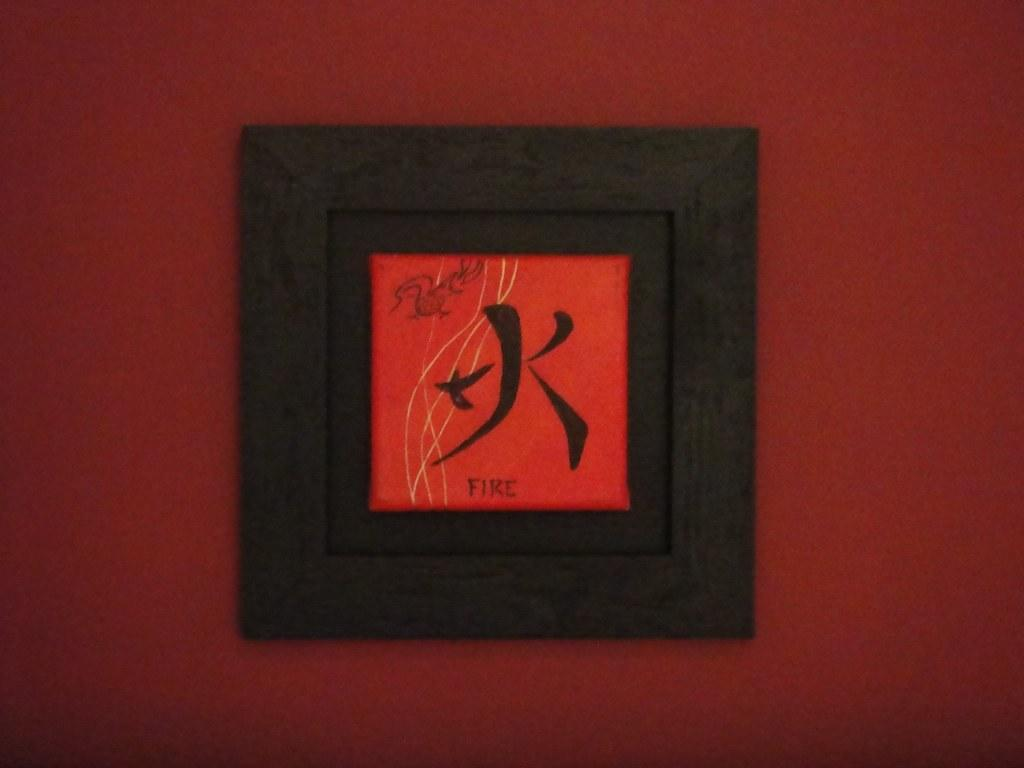Provide a one-sentence caption for the provided image. A framed out picture of a kanji character representing fire. 